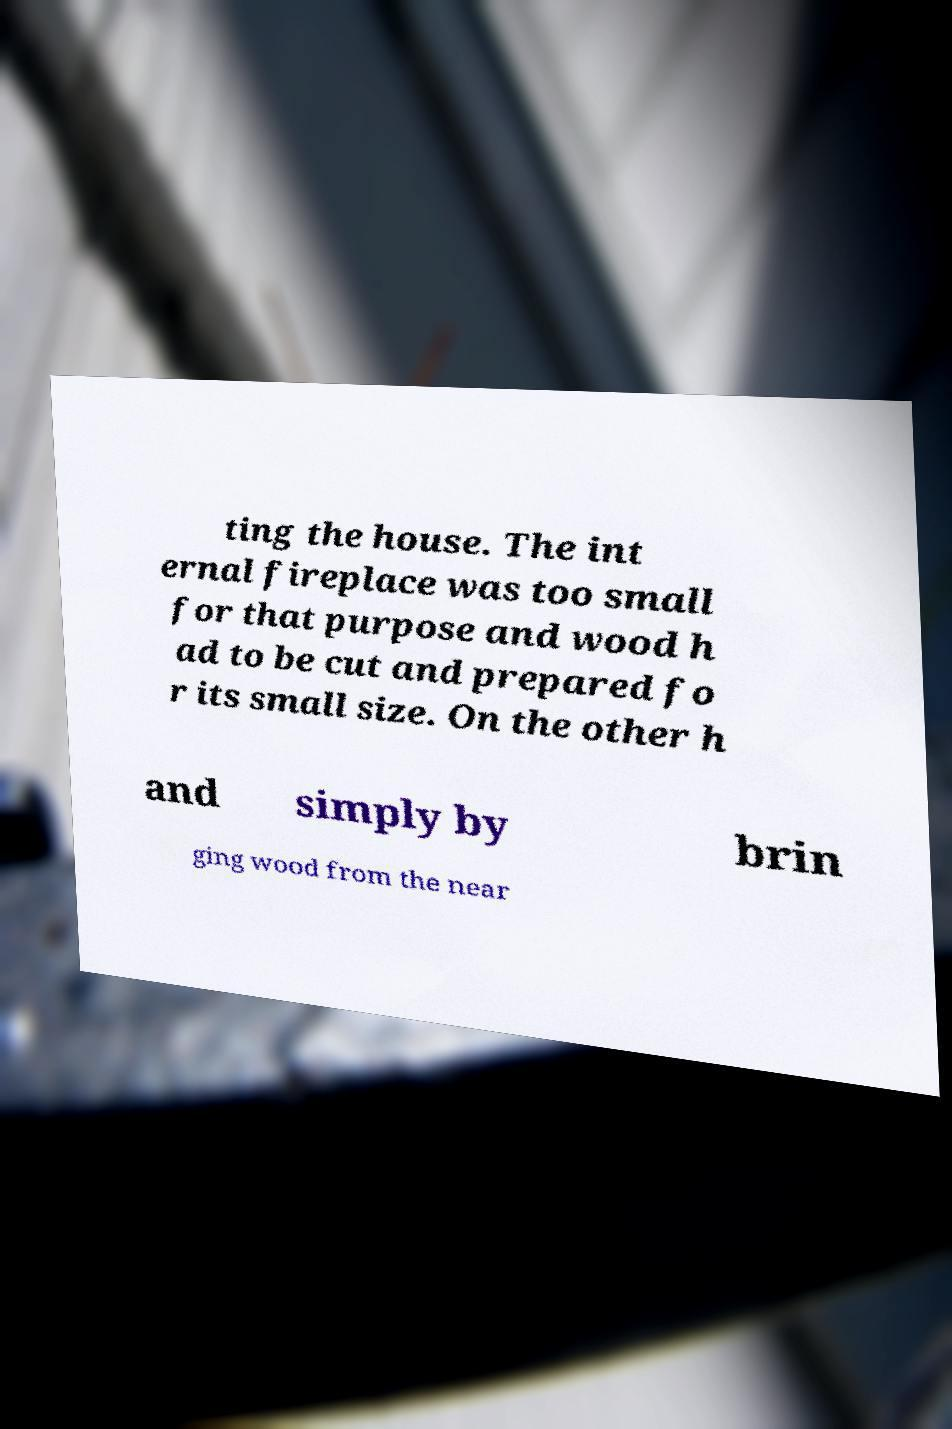I need the written content from this picture converted into text. Can you do that? ting the house. The int ernal fireplace was too small for that purpose and wood h ad to be cut and prepared fo r its small size. On the other h and simply by brin ging wood from the near 